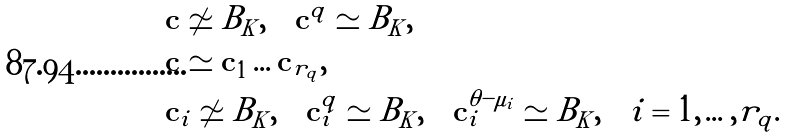Convert formula to latex. <formula><loc_0><loc_0><loc_500><loc_500>& \mathbf c \not \simeq B _ { K } , \quad \mathbf c ^ { q } \simeq B _ { K } , \\ & \mathbf c \simeq \mathbf c _ { 1 } \dots \mathbf c _ { r _ { q } } , \\ & \mathbf c _ { i } \not \simeq B _ { K } , \quad \mathbf c _ { i } ^ { q } \simeq B _ { K } , \quad \mathbf c _ { i } ^ { \theta - \mu _ { i } } \simeq B _ { K } , \quad i = 1 , \dots , r _ { q } .</formula> 